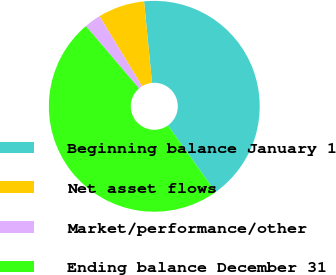Convert chart. <chart><loc_0><loc_0><loc_500><loc_500><pie_chart><fcel>Beginning balance January 1<fcel>Net asset flows<fcel>Market/performance/other<fcel>Ending balance December 31<nl><fcel>41.68%<fcel>7.15%<fcel>2.54%<fcel>48.64%<nl></chart> 